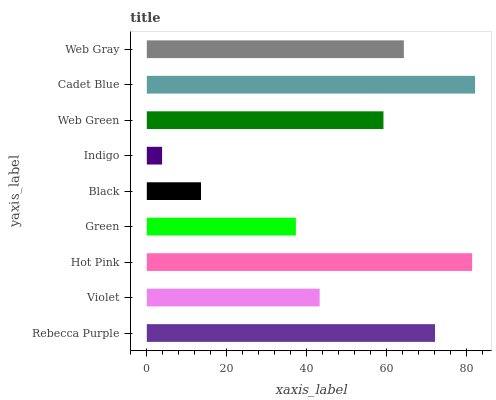Is Indigo the minimum?
Answer yes or no. Yes. Is Cadet Blue the maximum?
Answer yes or no. Yes. Is Violet the minimum?
Answer yes or no. No. Is Violet the maximum?
Answer yes or no. No. Is Rebecca Purple greater than Violet?
Answer yes or no. Yes. Is Violet less than Rebecca Purple?
Answer yes or no. Yes. Is Violet greater than Rebecca Purple?
Answer yes or no. No. Is Rebecca Purple less than Violet?
Answer yes or no. No. Is Web Green the high median?
Answer yes or no. Yes. Is Web Green the low median?
Answer yes or no. Yes. Is Green the high median?
Answer yes or no. No. Is Violet the low median?
Answer yes or no. No. 